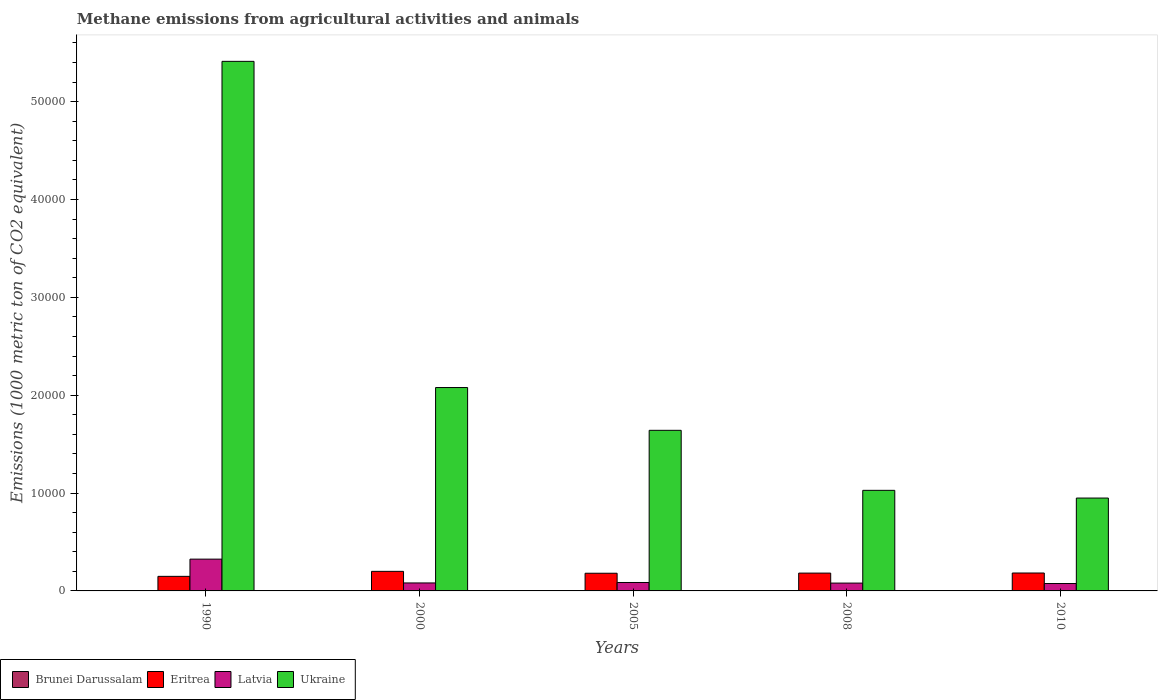Are the number of bars on each tick of the X-axis equal?
Keep it short and to the point. Yes. How many bars are there on the 3rd tick from the right?
Your answer should be compact. 4. What is the label of the 1st group of bars from the left?
Offer a very short reply. 1990. What is the amount of methane emitted in Ukraine in 2008?
Keep it short and to the point. 1.03e+04. Across all years, what is the maximum amount of methane emitted in Brunei Darussalam?
Keep it short and to the point. 15.3. Across all years, what is the minimum amount of methane emitted in Eritrea?
Provide a succinct answer. 1488.1. In which year was the amount of methane emitted in Eritrea minimum?
Give a very brief answer. 1990. What is the total amount of methane emitted in Brunei Darussalam in the graph?
Offer a very short reply. 70.6. What is the difference between the amount of methane emitted in Brunei Darussalam in 1990 and that in 2008?
Your answer should be very brief. -1.8. What is the difference between the amount of methane emitted in Latvia in 2005 and the amount of methane emitted in Ukraine in 1990?
Your response must be concise. -5.33e+04. What is the average amount of methane emitted in Brunei Darussalam per year?
Keep it short and to the point. 14.12. In the year 2000, what is the difference between the amount of methane emitted in Ukraine and amount of methane emitted in Latvia?
Offer a terse response. 2.00e+04. What is the ratio of the amount of methane emitted in Latvia in 2005 to that in 2008?
Provide a succinct answer. 1.07. Is the amount of methane emitted in Latvia in 2000 less than that in 2010?
Your answer should be very brief. No. What is the difference between the highest and the second highest amount of methane emitted in Latvia?
Your response must be concise. 2387.1. What is the difference between the highest and the lowest amount of methane emitted in Brunei Darussalam?
Provide a short and direct response. 2.8. In how many years, is the amount of methane emitted in Latvia greater than the average amount of methane emitted in Latvia taken over all years?
Offer a very short reply. 1. Is it the case that in every year, the sum of the amount of methane emitted in Latvia and amount of methane emitted in Eritrea is greater than the sum of amount of methane emitted in Ukraine and amount of methane emitted in Brunei Darussalam?
Offer a terse response. Yes. What does the 2nd bar from the left in 2005 represents?
Your answer should be very brief. Eritrea. What does the 4th bar from the right in 1990 represents?
Give a very brief answer. Brunei Darussalam. How many bars are there?
Provide a short and direct response. 20. Are all the bars in the graph horizontal?
Provide a short and direct response. No. Does the graph contain grids?
Make the answer very short. No. Where does the legend appear in the graph?
Your answer should be very brief. Bottom left. What is the title of the graph?
Provide a succinct answer. Methane emissions from agricultural activities and animals. Does "Jordan" appear as one of the legend labels in the graph?
Offer a very short reply. No. What is the label or title of the Y-axis?
Ensure brevity in your answer.  Emissions (1000 metric ton of CO2 equivalent). What is the Emissions (1000 metric ton of CO2 equivalent) in Eritrea in 1990?
Make the answer very short. 1488.1. What is the Emissions (1000 metric ton of CO2 equivalent) of Latvia in 1990?
Keep it short and to the point. 3247.8. What is the Emissions (1000 metric ton of CO2 equivalent) of Ukraine in 1990?
Your answer should be compact. 5.41e+04. What is the Emissions (1000 metric ton of CO2 equivalent) in Brunei Darussalam in 2000?
Offer a terse response. 15.3. What is the Emissions (1000 metric ton of CO2 equivalent) in Eritrea in 2000?
Offer a very short reply. 2000.3. What is the Emissions (1000 metric ton of CO2 equivalent) in Latvia in 2000?
Provide a succinct answer. 814.5. What is the Emissions (1000 metric ton of CO2 equivalent) in Ukraine in 2000?
Offer a terse response. 2.08e+04. What is the Emissions (1000 metric ton of CO2 equivalent) in Eritrea in 2005?
Offer a very short reply. 1806.6. What is the Emissions (1000 metric ton of CO2 equivalent) in Latvia in 2005?
Offer a very short reply. 860.7. What is the Emissions (1000 metric ton of CO2 equivalent) of Ukraine in 2005?
Provide a succinct answer. 1.64e+04. What is the Emissions (1000 metric ton of CO2 equivalent) of Eritrea in 2008?
Give a very brief answer. 1820.8. What is the Emissions (1000 metric ton of CO2 equivalent) in Latvia in 2008?
Provide a short and direct response. 800.8. What is the Emissions (1000 metric ton of CO2 equivalent) of Ukraine in 2008?
Your response must be concise. 1.03e+04. What is the Emissions (1000 metric ton of CO2 equivalent) of Eritrea in 2010?
Your answer should be very brief. 1829.8. What is the Emissions (1000 metric ton of CO2 equivalent) in Latvia in 2010?
Your response must be concise. 755.9. What is the Emissions (1000 metric ton of CO2 equivalent) in Ukraine in 2010?
Give a very brief answer. 9489.8. Across all years, what is the maximum Emissions (1000 metric ton of CO2 equivalent) of Eritrea?
Provide a succinct answer. 2000.3. Across all years, what is the maximum Emissions (1000 metric ton of CO2 equivalent) in Latvia?
Your answer should be compact. 3247.8. Across all years, what is the maximum Emissions (1000 metric ton of CO2 equivalent) of Ukraine?
Your answer should be compact. 5.41e+04. Across all years, what is the minimum Emissions (1000 metric ton of CO2 equivalent) in Brunei Darussalam?
Ensure brevity in your answer.  12.5. Across all years, what is the minimum Emissions (1000 metric ton of CO2 equivalent) of Eritrea?
Your response must be concise. 1488.1. Across all years, what is the minimum Emissions (1000 metric ton of CO2 equivalent) in Latvia?
Offer a very short reply. 755.9. Across all years, what is the minimum Emissions (1000 metric ton of CO2 equivalent) in Ukraine?
Give a very brief answer. 9489.8. What is the total Emissions (1000 metric ton of CO2 equivalent) in Brunei Darussalam in the graph?
Provide a succinct answer. 70.6. What is the total Emissions (1000 metric ton of CO2 equivalent) in Eritrea in the graph?
Keep it short and to the point. 8945.6. What is the total Emissions (1000 metric ton of CO2 equivalent) in Latvia in the graph?
Ensure brevity in your answer.  6479.7. What is the total Emissions (1000 metric ton of CO2 equivalent) in Ukraine in the graph?
Give a very brief answer. 1.11e+05. What is the difference between the Emissions (1000 metric ton of CO2 equivalent) of Brunei Darussalam in 1990 and that in 2000?
Keep it short and to the point. -2.8. What is the difference between the Emissions (1000 metric ton of CO2 equivalent) in Eritrea in 1990 and that in 2000?
Offer a very short reply. -512.2. What is the difference between the Emissions (1000 metric ton of CO2 equivalent) of Latvia in 1990 and that in 2000?
Offer a very short reply. 2433.3. What is the difference between the Emissions (1000 metric ton of CO2 equivalent) in Ukraine in 1990 and that in 2000?
Ensure brevity in your answer.  3.33e+04. What is the difference between the Emissions (1000 metric ton of CO2 equivalent) of Eritrea in 1990 and that in 2005?
Keep it short and to the point. -318.5. What is the difference between the Emissions (1000 metric ton of CO2 equivalent) of Latvia in 1990 and that in 2005?
Offer a very short reply. 2387.1. What is the difference between the Emissions (1000 metric ton of CO2 equivalent) in Ukraine in 1990 and that in 2005?
Offer a terse response. 3.77e+04. What is the difference between the Emissions (1000 metric ton of CO2 equivalent) of Brunei Darussalam in 1990 and that in 2008?
Keep it short and to the point. -1.8. What is the difference between the Emissions (1000 metric ton of CO2 equivalent) of Eritrea in 1990 and that in 2008?
Your answer should be very brief. -332.7. What is the difference between the Emissions (1000 metric ton of CO2 equivalent) in Latvia in 1990 and that in 2008?
Offer a very short reply. 2447. What is the difference between the Emissions (1000 metric ton of CO2 equivalent) of Ukraine in 1990 and that in 2008?
Keep it short and to the point. 4.38e+04. What is the difference between the Emissions (1000 metric ton of CO2 equivalent) of Brunei Darussalam in 1990 and that in 2010?
Offer a terse response. -1.9. What is the difference between the Emissions (1000 metric ton of CO2 equivalent) of Eritrea in 1990 and that in 2010?
Your answer should be very brief. -341.7. What is the difference between the Emissions (1000 metric ton of CO2 equivalent) of Latvia in 1990 and that in 2010?
Make the answer very short. 2491.9. What is the difference between the Emissions (1000 metric ton of CO2 equivalent) in Ukraine in 1990 and that in 2010?
Your answer should be compact. 4.46e+04. What is the difference between the Emissions (1000 metric ton of CO2 equivalent) of Brunei Darussalam in 2000 and that in 2005?
Your answer should be very brief. 1.2. What is the difference between the Emissions (1000 metric ton of CO2 equivalent) in Eritrea in 2000 and that in 2005?
Offer a terse response. 193.7. What is the difference between the Emissions (1000 metric ton of CO2 equivalent) in Latvia in 2000 and that in 2005?
Ensure brevity in your answer.  -46.2. What is the difference between the Emissions (1000 metric ton of CO2 equivalent) of Ukraine in 2000 and that in 2005?
Give a very brief answer. 4372.1. What is the difference between the Emissions (1000 metric ton of CO2 equivalent) in Brunei Darussalam in 2000 and that in 2008?
Your response must be concise. 1. What is the difference between the Emissions (1000 metric ton of CO2 equivalent) in Eritrea in 2000 and that in 2008?
Offer a very short reply. 179.5. What is the difference between the Emissions (1000 metric ton of CO2 equivalent) in Latvia in 2000 and that in 2008?
Your answer should be very brief. 13.7. What is the difference between the Emissions (1000 metric ton of CO2 equivalent) in Ukraine in 2000 and that in 2008?
Make the answer very short. 1.05e+04. What is the difference between the Emissions (1000 metric ton of CO2 equivalent) in Eritrea in 2000 and that in 2010?
Give a very brief answer. 170.5. What is the difference between the Emissions (1000 metric ton of CO2 equivalent) in Latvia in 2000 and that in 2010?
Provide a succinct answer. 58.6. What is the difference between the Emissions (1000 metric ton of CO2 equivalent) of Ukraine in 2000 and that in 2010?
Give a very brief answer. 1.13e+04. What is the difference between the Emissions (1000 metric ton of CO2 equivalent) in Eritrea in 2005 and that in 2008?
Ensure brevity in your answer.  -14.2. What is the difference between the Emissions (1000 metric ton of CO2 equivalent) of Latvia in 2005 and that in 2008?
Provide a succinct answer. 59.9. What is the difference between the Emissions (1000 metric ton of CO2 equivalent) in Ukraine in 2005 and that in 2008?
Your answer should be compact. 6133.4. What is the difference between the Emissions (1000 metric ton of CO2 equivalent) of Brunei Darussalam in 2005 and that in 2010?
Ensure brevity in your answer.  -0.3. What is the difference between the Emissions (1000 metric ton of CO2 equivalent) in Eritrea in 2005 and that in 2010?
Offer a terse response. -23.2. What is the difference between the Emissions (1000 metric ton of CO2 equivalent) of Latvia in 2005 and that in 2010?
Your response must be concise. 104.8. What is the difference between the Emissions (1000 metric ton of CO2 equivalent) in Ukraine in 2005 and that in 2010?
Provide a short and direct response. 6921.6. What is the difference between the Emissions (1000 metric ton of CO2 equivalent) in Brunei Darussalam in 2008 and that in 2010?
Your response must be concise. -0.1. What is the difference between the Emissions (1000 metric ton of CO2 equivalent) of Eritrea in 2008 and that in 2010?
Provide a short and direct response. -9. What is the difference between the Emissions (1000 metric ton of CO2 equivalent) in Latvia in 2008 and that in 2010?
Offer a very short reply. 44.9. What is the difference between the Emissions (1000 metric ton of CO2 equivalent) of Ukraine in 2008 and that in 2010?
Make the answer very short. 788.2. What is the difference between the Emissions (1000 metric ton of CO2 equivalent) in Brunei Darussalam in 1990 and the Emissions (1000 metric ton of CO2 equivalent) in Eritrea in 2000?
Your response must be concise. -1987.8. What is the difference between the Emissions (1000 metric ton of CO2 equivalent) of Brunei Darussalam in 1990 and the Emissions (1000 metric ton of CO2 equivalent) of Latvia in 2000?
Give a very brief answer. -802. What is the difference between the Emissions (1000 metric ton of CO2 equivalent) in Brunei Darussalam in 1990 and the Emissions (1000 metric ton of CO2 equivalent) in Ukraine in 2000?
Your answer should be very brief. -2.08e+04. What is the difference between the Emissions (1000 metric ton of CO2 equivalent) of Eritrea in 1990 and the Emissions (1000 metric ton of CO2 equivalent) of Latvia in 2000?
Give a very brief answer. 673.6. What is the difference between the Emissions (1000 metric ton of CO2 equivalent) of Eritrea in 1990 and the Emissions (1000 metric ton of CO2 equivalent) of Ukraine in 2000?
Offer a very short reply. -1.93e+04. What is the difference between the Emissions (1000 metric ton of CO2 equivalent) in Latvia in 1990 and the Emissions (1000 metric ton of CO2 equivalent) in Ukraine in 2000?
Your answer should be very brief. -1.75e+04. What is the difference between the Emissions (1000 metric ton of CO2 equivalent) in Brunei Darussalam in 1990 and the Emissions (1000 metric ton of CO2 equivalent) in Eritrea in 2005?
Make the answer very short. -1794.1. What is the difference between the Emissions (1000 metric ton of CO2 equivalent) of Brunei Darussalam in 1990 and the Emissions (1000 metric ton of CO2 equivalent) of Latvia in 2005?
Ensure brevity in your answer.  -848.2. What is the difference between the Emissions (1000 metric ton of CO2 equivalent) in Brunei Darussalam in 1990 and the Emissions (1000 metric ton of CO2 equivalent) in Ukraine in 2005?
Ensure brevity in your answer.  -1.64e+04. What is the difference between the Emissions (1000 metric ton of CO2 equivalent) of Eritrea in 1990 and the Emissions (1000 metric ton of CO2 equivalent) of Latvia in 2005?
Provide a short and direct response. 627.4. What is the difference between the Emissions (1000 metric ton of CO2 equivalent) of Eritrea in 1990 and the Emissions (1000 metric ton of CO2 equivalent) of Ukraine in 2005?
Your response must be concise. -1.49e+04. What is the difference between the Emissions (1000 metric ton of CO2 equivalent) in Latvia in 1990 and the Emissions (1000 metric ton of CO2 equivalent) in Ukraine in 2005?
Give a very brief answer. -1.32e+04. What is the difference between the Emissions (1000 metric ton of CO2 equivalent) in Brunei Darussalam in 1990 and the Emissions (1000 metric ton of CO2 equivalent) in Eritrea in 2008?
Keep it short and to the point. -1808.3. What is the difference between the Emissions (1000 metric ton of CO2 equivalent) in Brunei Darussalam in 1990 and the Emissions (1000 metric ton of CO2 equivalent) in Latvia in 2008?
Keep it short and to the point. -788.3. What is the difference between the Emissions (1000 metric ton of CO2 equivalent) of Brunei Darussalam in 1990 and the Emissions (1000 metric ton of CO2 equivalent) of Ukraine in 2008?
Offer a terse response. -1.03e+04. What is the difference between the Emissions (1000 metric ton of CO2 equivalent) of Eritrea in 1990 and the Emissions (1000 metric ton of CO2 equivalent) of Latvia in 2008?
Provide a short and direct response. 687.3. What is the difference between the Emissions (1000 metric ton of CO2 equivalent) in Eritrea in 1990 and the Emissions (1000 metric ton of CO2 equivalent) in Ukraine in 2008?
Your answer should be compact. -8789.9. What is the difference between the Emissions (1000 metric ton of CO2 equivalent) in Latvia in 1990 and the Emissions (1000 metric ton of CO2 equivalent) in Ukraine in 2008?
Provide a succinct answer. -7030.2. What is the difference between the Emissions (1000 metric ton of CO2 equivalent) in Brunei Darussalam in 1990 and the Emissions (1000 metric ton of CO2 equivalent) in Eritrea in 2010?
Provide a short and direct response. -1817.3. What is the difference between the Emissions (1000 metric ton of CO2 equivalent) of Brunei Darussalam in 1990 and the Emissions (1000 metric ton of CO2 equivalent) of Latvia in 2010?
Provide a short and direct response. -743.4. What is the difference between the Emissions (1000 metric ton of CO2 equivalent) in Brunei Darussalam in 1990 and the Emissions (1000 metric ton of CO2 equivalent) in Ukraine in 2010?
Offer a terse response. -9477.3. What is the difference between the Emissions (1000 metric ton of CO2 equivalent) in Eritrea in 1990 and the Emissions (1000 metric ton of CO2 equivalent) in Latvia in 2010?
Your answer should be very brief. 732.2. What is the difference between the Emissions (1000 metric ton of CO2 equivalent) in Eritrea in 1990 and the Emissions (1000 metric ton of CO2 equivalent) in Ukraine in 2010?
Make the answer very short. -8001.7. What is the difference between the Emissions (1000 metric ton of CO2 equivalent) of Latvia in 1990 and the Emissions (1000 metric ton of CO2 equivalent) of Ukraine in 2010?
Give a very brief answer. -6242. What is the difference between the Emissions (1000 metric ton of CO2 equivalent) of Brunei Darussalam in 2000 and the Emissions (1000 metric ton of CO2 equivalent) of Eritrea in 2005?
Provide a short and direct response. -1791.3. What is the difference between the Emissions (1000 metric ton of CO2 equivalent) in Brunei Darussalam in 2000 and the Emissions (1000 metric ton of CO2 equivalent) in Latvia in 2005?
Your answer should be compact. -845.4. What is the difference between the Emissions (1000 metric ton of CO2 equivalent) of Brunei Darussalam in 2000 and the Emissions (1000 metric ton of CO2 equivalent) of Ukraine in 2005?
Keep it short and to the point. -1.64e+04. What is the difference between the Emissions (1000 metric ton of CO2 equivalent) of Eritrea in 2000 and the Emissions (1000 metric ton of CO2 equivalent) of Latvia in 2005?
Ensure brevity in your answer.  1139.6. What is the difference between the Emissions (1000 metric ton of CO2 equivalent) of Eritrea in 2000 and the Emissions (1000 metric ton of CO2 equivalent) of Ukraine in 2005?
Provide a short and direct response. -1.44e+04. What is the difference between the Emissions (1000 metric ton of CO2 equivalent) in Latvia in 2000 and the Emissions (1000 metric ton of CO2 equivalent) in Ukraine in 2005?
Your response must be concise. -1.56e+04. What is the difference between the Emissions (1000 metric ton of CO2 equivalent) in Brunei Darussalam in 2000 and the Emissions (1000 metric ton of CO2 equivalent) in Eritrea in 2008?
Ensure brevity in your answer.  -1805.5. What is the difference between the Emissions (1000 metric ton of CO2 equivalent) of Brunei Darussalam in 2000 and the Emissions (1000 metric ton of CO2 equivalent) of Latvia in 2008?
Provide a short and direct response. -785.5. What is the difference between the Emissions (1000 metric ton of CO2 equivalent) of Brunei Darussalam in 2000 and the Emissions (1000 metric ton of CO2 equivalent) of Ukraine in 2008?
Make the answer very short. -1.03e+04. What is the difference between the Emissions (1000 metric ton of CO2 equivalent) of Eritrea in 2000 and the Emissions (1000 metric ton of CO2 equivalent) of Latvia in 2008?
Make the answer very short. 1199.5. What is the difference between the Emissions (1000 metric ton of CO2 equivalent) in Eritrea in 2000 and the Emissions (1000 metric ton of CO2 equivalent) in Ukraine in 2008?
Provide a succinct answer. -8277.7. What is the difference between the Emissions (1000 metric ton of CO2 equivalent) in Latvia in 2000 and the Emissions (1000 metric ton of CO2 equivalent) in Ukraine in 2008?
Provide a succinct answer. -9463.5. What is the difference between the Emissions (1000 metric ton of CO2 equivalent) of Brunei Darussalam in 2000 and the Emissions (1000 metric ton of CO2 equivalent) of Eritrea in 2010?
Provide a short and direct response. -1814.5. What is the difference between the Emissions (1000 metric ton of CO2 equivalent) in Brunei Darussalam in 2000 and the Emissions (1000 metric ton of CO2 equivalent) in Latvia in 2010?
Offer a very short reply. -740.6. What is the difference between the Emissions (1000 metric ton of CO2 equivalent) in Brunei Darussalam in 2000 and the Emissions (1000 metric ton of CO2 equivalent) in Ukraine in 2010?
Offer a terse response. -9474.5. What is the difference between the Emissions (1000 metric ton of CO2 equivalent) in Eritrea in 2000 and the Emissions (1000 metric ton of CO2 equivalent) in Latvia in 2010?
Make the answer very short. 1244.4. What is the difference between the Emissions (1000 metric ton of CO2 equivalent) in Eritrea in 2000 and the Emissions (1000 metric ton of CO2 equivalent) in Ukraine in 2010?
Offer a terse response. -7489.5. What is the difference between the Emissions (1000 metric ton of CO2 equivalent) in Latvia in 2000 and the Emissions (1000 metric ton of CO2 equivalent) in Ukraine in 2010?
Make the answer very short. -8675.3. What is the difference between the Emissions (1000 metric ton of CO2 equivalent) of Brunei Darussalam in 2005 and the Emissions (1000 metric ton of CO2 equivalent) of Eritrea in 2008?
Your answer should be very brief. -1806.7. What is the difference between the Emissions (1000 metric ton of CO2 equivalent) in Brunei Darussalam in 2005 and the Emissions (1000 metric ton of CO2 equivalent) in Latvia in 2008?
Provide a succinct answer. -786.7. What is the difference between the Emissions (1000 metric ton of CO2 equivalent) in Brunei Darussalam in 2005 and the Emissions (1000 metric ton of CO2 equivalent) in Ukraine in 2008?
Your answer should be very brief. -1.03e+04. What is the difference between the Emissions (1000 metric ton of CO2 equivalent) in Eritrea in 2005 and the Emissions (1000 metric ton of CO2 equivalent) in Latvia in 2008?
Provide a short and direct response. 1005.8. What is the difference between the Emissions (1000 metric ton of CO2 equivalent) in Eritrea in 2005 and the Emissions (1000 metric ton of CO2 equivalent) in Ukraine in 2008?
Provide a short and direct response. -8471.4. What is the difference between the Emissions (1000 metric ton of CO2 equivalent) of Latvia in 2005 and the Emissions (1000 metric ton of CO2 equivalent) of Ukraine in 2008?
Make the answer very short. -9417.3. What is the difference between the Emissions (1000 metric ton of CO2 equivalent) in Brunei Darussalam in 2005 and the Emissions (1000 metric ton of CO2 equivalent) in Eritrea in 2010?
Provide a succinct answer. -1815.7. What is the difference between the Emissions (1000 metric ton of CO2 equivalent) of Brunei Darussalam in 2005 and the Emissions (1000 metric ton of CO2 equivalent) of Latvia in 2010?
Your answer should be very brief. -741.8. What is the difference between the Emissions (1000 metric ton of CO2 equivalent) in Brunei Darussalam in 2005 and the Emissions (1000 metric ton of CO2 equivalent) in Ukraine in 2010?
Ensure brevity in your answer.  -9475.7. What is the difference between the Emissions (1000 metric ton of CO2 equivalent) of Eritrea in 2005 and the Emissions (1000 metric ton of CO2 equivalent) of Latvia in 2010?
Your answer should be very brief. 1050.7. What is the difference between the Emissions (1000 metric ton of CO2 equivalent) of Eritrea in 2005 and the Emissions (1000 metric ton of CO2 equivalent) of Ukraine in 2010?
Your answer should be very brief. -7683.2. What is the difference between the Emissions (1000 metric ton of CO2 equivalent) of Latvia in 2005 and the Emissions (1000 metric ton of CO2 equivalent) of Ukraine in 2010?
Make the answer very short. -8629.1. What is the difference between the Emissions (1000 metric ton of CO2 equivalent) of Brunei Darussalam in 2008 and the Emissions (1000 metric ton of CO2 equivalent) of Eritrea in 2010?
Offer a terse response. -1815.5. What is the difference between the Emissions (1000 metric ton of CO2 equivalent) of Brunei Darussalam in 2008 and the Emissions (1000 metric ton of CO2 equivalent) of Latvia in 2010?
Keep it short and to the point. -741.6. What is the difference between the Emissions (1000 metric ton of CO2 equivalent) of Brunei Darussalam in 2008 and the Emissions (1000 metric ton of CO2 equivalent) of Ukraine in 2010?
Your answer should be very brief. -9475.5. What is the difference between the Emissions (1000 metric ton of CO2 equivalent) of Eritrea in 2008 and the Emissions (1000 metric ton of CO2 equivalent) of Latvia in 2010?
Your answer should be compact. 1064.9. What is the difference between the Emissions (1000 metric ton of CO2 equivalent) of Eritrea in 2008 and the Emissions (1000 metric ton of CO2 equivalent) of Ukraine in 2010?
Your answer should be compact. -7669. What is the difference between the Emissions (1000 metric ton of CO2 equivalent) in Latvia in 2008 and the Emissions (1000 metric ton of CO2 equivalent) in Ukraine in 2010?
Offer a very short reply. -8689. What is the average Emissions (1000 metric ton of CO2 equivalent) of Brunei Darussalam per year?
Your response must be concise. 14.12. What is the average Emissions (1000 metric ton of CO2 equivalent) of Eritrea per year?
Your answer should be very brief. 1789.12. What is the average Emissions (1000 metric ton of CO2 equivalent) in Latvia per year?
Provide a succinct answer. 1295.94. What is the average Emissions (1000 metric ton of CO2 equivalent) of Ukraine per year?
Make the answer very short. 2.22e+04. In the year 1990, what is the difference between the Emissions (1000 metric ton of CO2 equivalent) in Brunei Darussalam and Emissions (1000 metric ton of CO2 equivalent) in Eritrea?
Your answer should be very brief. -1475.6. In the year 1990, what is the difference between the Emissions (1000 metric ton of CO2 equivalent) of Brunei Darussalam and Emissions (1000 metric ton of CO2 equivalent) of Latvia?
Make the answer very short. -3235.3. In the year 1990, what is the difference between the Emissions (1000 metric ton of CO2 equivalent) of Brunei Darussalam and Emissions (1000 metric ton of CO2 equivalent) of Ukraine?
Your response must be concise. -5.41e+04. In the year 1990, what is the difference between the Emissions (1000 metric ton of CO2 equivalent) in Eritrea and Emissions (1000 metric ton of CO2 equivalent) in Latvia?
Give a very brief answer. -1759.7. In the year 1990, what is the difference between the Emissions (1000 metric ton of CO2 equivalent) in Eritrea and Emissions (1000 metric ton of CO2 equivalent) in Ukraine?
Make the answer very short. -5.26e+04. In the year 1990, what is the difference between the Emissions (1000 metric ton of CO2 equivalent) of Latvia and Emissions (1000 metric ton of CO2 equivalent) of Ukraine?
Make the answer very short. -5.09e+04. In the year 2000, what is the difference between the Emissions (1000 metric ton of CO2 equivalent) in Brunei Darussalam and Emissions (1000 metric ton of CO2 equivalent) in Eritrea?
Your answer should be compact. -1985. In the year 2000, what is the difference between the Emissions (1000 metric ton of CO2 equivalent) of Brunei Darussalam and Emissions (1000 metric ton of CO2 equivalent) of Latvia?
Provide a succinct answer. -799.2. In the year 2000, what is the difference between the Emissions (1000 metric ton of CO2 equivalent) of Brunei Darussalam and Emissions (1000 metric ton of CO2 equivalent) of Ukraine?
Your answer should be compact. -2.08e+04. In the year 2000, what is the difference between the Emissions (1000 metric ton of CO2 equivalent) of Eritrea and Emissions (1000 metric ton of CO2 equivalent) of Latvia?
Your response must be concise. 1185.8. In the year 2000, what is the difference between the Emissions (1000 metric ton of CO2 equivalent) of Eritrea and Emissions (1000 metric ton of CO2 equivalent) of Ukraine?
Ensure brevity in your answer.  -1.88e+04. In the year 2000, what is the difference between the Emissions (1000 metric ton of CO2 equivalent) in Latvia and Emissions (1000 metric ton of CO2 equivalent) in Ukraine?
Give a very brief answer. -2.00e+04. In the year 2005, what is the difference between the Emissions (1000 metric ton of CO2 equivalent) in Brunei Darussalam and Emissions (1000 metric ton of CO2 equivalent) in Eritrea?
Your response must be concise. -1792.5. In the year 2005, what is the difference between the Emissions (1000 metric ton of CO2 equivalent) of Brunei Darussalam and Emissions (1000 metric ton of CO2 equivalent) of Latvia?
Ensure brevity in your answer.  -846.6. In the year 2005, what is the difference between the Emissions (1000 metric ton of CO2 equivalent) of Brunei Darussalam and Emissions (1000 metric ton of CO2 equivalent) of Ukraine?
Provide a short and direct response. -1.64e+04. In the year 2005, what is the difference between the Emissions (1000 metric ton of CO2 equivalent) of Eritrea and Emissions (1000 metric ton of CO2 equivalent) of Latvia?
Offer a terse response. 945.9. In the year 2005, what is the difference between the Emissions (1000 metric ton of CO2 equivalent) of Eritrea and Emissions (1000 metric ton of CO2 equivalent) of Ukraine?
Offer a terse response. -1.46e+04. In the year 2005, what is the difference between the Emissions (1000 metric ton of CO2 equivalent) in Latvia and Emissions (1000 metric ton of CO2 equivalent) in Ukraine?
Provide a succinct answer. -1.56e+04. In the year 2008, what is the difference between the Emissions (1000 metric ton of CO2 equivalent) in Brunei Darussalam and Emissions (1000 metric ton of CO2 equivalent) in Eritrea?
Your response must be concise. -1806.5. In the year 2008, what is the difference between the Emissions (1000 metric ton of CO2 equivalent) in Brunei Darussalam and Emissions (1000 metric ton of CO2 equivalent) in Latvia?
Provide a succinct answer. -786.5. In the year 2008, what is the difference between the Emissions (1000 metric ton of CO2 equivalent) in Brunei Darussalam and Emissions (1000 metric ton of CO2 equivalent) in Ukraine?
Keep it short and to the point. -1.03e+04. In the year 2008, what is the difference between the Emissions (1000 metric ton of CO2 equivalent) of Eritrea and Emissions (1000 metric ton of CO2 equivalent) of Latvia?
Keep it short and to the point. 1020. In the year 2008, what is the difference between the Emissions (1000 metric ton of CO2 equivalent) in Eritrea and Emissions (1000 metric ton of CO2 equivalent) in Ukraine?
Give a very brief answer. -8457.2. In the year 2008, what is the difference between the Emissions (1000 metric ton of CO2 equivalent) in Latvia and Emissions (1000 metric ton of CO2 equivalent) in Ukraine?
Provide a short and direct response. -9477.2. In the year 2010, what is the difference between the Emissions (1000 metric ton of CO2 equivalent) in Brunei Darussalam and Emissions (1000 metric ton of CO2 equivalent) in Eritrea?
Your answer should be compact. -1815.4. In the year 2010, what is the difference between the Emissions (1000 metric ton of CO2 equivalent) in Brunei Darussalam and Emissions (1000 metric ton of CO2 equivalent) in Latvia?
Ensure brevity in your answer.  -741.5. In the year 2010, what is the difference between the Emissions (1000 metric ton of CO2 equivalent) of Brunei Darussalam and Emissions (1000 metric ton of CO2 equivalent) of Ukraine?
Offer a terse response. -9475.4. In the year 2010, what is the difference between the Emissions (1000 metric ton of CO2 equivalent) of Eritrea and Emissions (1000 metric ton of CO2 equivalent) of Latvia?
Offer a very short reply. 1073.9. In the year 2010, what is the difference between the Emissions (1000 metric ton of CO2 equivalent) in Eritrea and Emissions (1000 metric ton of CO2 equivalent) in Ukraine?
Provide a short and direct response. -7660. In the year 2010, what is the difference between the Emissions (1000 metric ton of CO2 equivalent) of Latvia and Emissions (1000 metric ton of CO2 equivalent) of Ukraine?
Offer a terse response. -8733.9. What is the ratio of the Emissions (1000 metric ton of CO2 equivalent) of Brunei Darussalam in 1990 to that in 2000?
Offer a terse response. 0.82. What is the ratio of the Emissions (1000 metric ton of CO2 equivalent) of Eritrea in 1990 to that in 2000?
Your response must be concise. 0.74. What is the ratio of the Emissions (1000 metric ton of CO2 equivalent) of Latvia in 1990 to that in 2000?
Offer a very short reply. 3.99. What is the ratio of the Emissions (1000 metric ton of CO2 equivalent) of Ukraine in 1990 to that in 2000?
Your response must be concise. 2.6. What is the ratio of the Emissions (1000 metric ton of CO2 equivalent) of Brunei Darussalam in 1990 to that in 2005?
Offer a terse response. 0.89. What is the ratio of the Emissions (1000 metric ton of CO2 equivalent) of Eritrea in 1990 to that in 2005?
Provide a succinct answer. 0.82. What is the ratio of the Emissions (1000 metric ton of CO2 equivalent) in Latvia in 1990 to that in 2005?
Provide a succinct answer. 3.77. What is the ratio of the Emissions (1000 metric ton of CO2 equivalent) of Ukraine in 1990 to that in 2005?
Ensure brevity in your answer.  3.3. What is the ratio of the Emissions (1000 metric ton of CO2 equivalent) in Brunei Darussalam in 1990 to that in 2008?
Your response must be concise. 0.87. What is the ratio of the Emissions (1000 metric ton of CO2 equivalent) in Eritrea in 1990 to that in 2008?
Your answer should be compact. 0.82. What is the ratio of the Emissions (1000 metric ton of CO2 equivalent) in Latvia in 1990 to that in 2008?
Give a very brief answer. 4.06. What is the ratio of the Emissions (1000 metric ton of CO2 equivalent) in Ukraine in 1990 to that in 2008?
Offer a very short reply. 5.27. What is the ratio of the Emissions (1000 metric ton of CO2 equivalent) of Brunei Darussalam in 1990 to that in 2010?
Make the answer very short. 0.87. What is the ratio of the Emissions (1000 metric ton of CO2 equivalent) in Eritrea in 1990 to that in 2010?
Your response must be concise. 0.81. What is the ratio of the Emissions (1000 metric ton of CO2 equivalent) of Latvia in 1990 to that in 2010?
Provide a succinct answer. 4.3. What is the ratio of the Emissions (1000 metric ton of CO2 equivalent) in Ukraine in 1990 to that in 2010?
Ensure brevity in your answer.  5.7. What is the ratio of the Emissions (1000 metric ton of CO2 equivalent) of Brunei Darussalam in 2000 to that in 2005?
Ensure brevity in your answer.  1.09. What is the ratio of the Emissions (1000 metric ton of CO2 equivalent) of Eritrea in 2000 to that in 2005?
Offer a very short reply. 1.11. What is the ratio of the Emissions (1000 metric ton of CO2 equivalent) of Latvia in 2000 to that in 2005?
Keep it short and to the point. 0.95. What is the ratio of the Emissions (1000 metric ton of CO2 equivalent) in Ukraine in 2000 to that in 2005?
Your answer should be very brief. 1.27. What is the ratio of the Emissions (1000 metric ton of CO2 equivalent) in Brunei Darussalam in 2000 to that in 2008?
Your response must be concise. 1.07. What is the ratio of the Emissions (1000 metric ton of CO2 equivalent) in Eritrea in 2000 to that in 2008?
Offer a terse response. 1.1. What is the ratio of the Emissions (1000 metric ton of CO2 equivalent) of Latvia in 2000 to that in 2008?
Give a very brief answer. 1.02. What is the ratio of the Emissions (1000 metric ton of CO2 equivalent) in Ukraine in 2000 to that in 2008?
Offer a very short reply. 2.02. What is the ratio of the Emissions (1000 metric ton of CO2 equivalent) in Brunei Darussalam in 2000 to that in 2010?
Offer a very short reply. 1.06. What is the ratio of the Emissions (1000 metric ton of CO2 equivalent) in Eritrea in 2000 to that in 2010?
Make the answer very short. 1.09. What is the ratio of the Emissions (1000 metric ton of CO2 equivalent) in Latvia in 2000 to that in 2010?
Offer a very short reply. 1.08. What is the ratio of the Emissions (1000 metric ton of CO2 equivalent) of Ukraine in 2000 to that in 2010?
Provide a short and direct response. 2.19. What is the ratio of the Emissions (1000 metric ton of CO2 equivalent) in Brunei Darussalam in 2005 to that in 2008?
Make the answer very short. 0.99. What is the ratio of the Emissions (1000 metric ton of CO2 equivalent) of Eritrea in 2005 to that in 2008?
Give a very brief answer. 0.99. What is the ratio of the Emissions (1000 metric ton of CO2 equivalent) of Latvia in 2005 to that in 2008?
Provide a short and direct response. 1.07. What is the ratio of the Emissions (1000 metric ton of CO2 equivalent) in Ukraine in 2005 to that in 2008?
Provide a succinct answer. 1.6. What is the ratio of the Emissions (1000 metric ton of CO2 equivalent) of Brunei Darussalam in 2005 to that in 2010?
Offer a terse response. 0.98. What is the ratio of the Emissions (1000 metric ton of CO2 equivalent) in Eritrea in 2005 to that in 2010?
Keep it short and to the point. 0.99. What is the ratio of the Emissions (1000 metric ton of CO2 equivalent) of Latvia in 2005 to that in 2010?
Offer a very short reply. 1.14. What is the ratio of the Emissions (1000 metric ton of CO2 equivalent) of Ukraine in 2005 to that in 2010?
Offer a terse response. 1.73. What is the ratio of the Emissions (1000 metric ton of CO2 equivalent) of Brunei Darussalam in 2008 to that in 2010?
Your response must be concise. 0.99. What is the ratio of the Emissions (1000 metric ton of CO2 equivalent) in Latvia in 2008 to that in 2010?
Offer a terse response. 1.06. What is the ratio of the Emissions (1000 metric ton of CO2 equivalent) in Ukraine in 2008 to that in 2010?
Your answer should be compact. 1.08. What is the difference between the highest and the second highest Emissions (1000 metric ton of CO2 equivalent) of Brunei Darussalam?
Provide a short and direct response. 0.9. What is the difference between the highest and the second highest Emissions (1000 metric ton of CO2 equivalent) in Eritrea?
Give a very brief answer. 170.5. What is the difference between the highest and the second highest Emissions (1000 metric ton of CO2 equivalent) of Latvia?
Keep it short and to the point. 2387.1. What is the difference between the highest and the second highest Emissions (1000 metric ton of CO2 equivalent) of Ukraine?
Your response must be concise. 3.33e+04. What is the difference between the highest and the lowest Emissions (1000 metric ton of CO2 equivalent) in Brunei Darussalam?
Give a very brief answer. 2.8. What is the difference between the highest and the lowest Emissions (1000 metric ton of CO2 equivalent) in Eritrea?
Provide a succinct answer. 512.2. What is the difference between the highest and the lowest Emissions (1000 metric ton of CO2 equivalent) of Latvia?
Keep it short and to the point. 2491.9. What is the difference between the highest and the lowest Emissions (1000 metric ton of CO2 equivalent) in Ukraine?
Provide a short and direct response. 4.46e+04. 